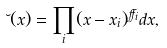Convert formula to latex. <formula><loc_0><loc_0><loc_500><loc_500>\lambda ( x ) = \prod _ { i } ( x - x _ { i } ) ^ { \alpha _ { i } } d x ,</formula> 